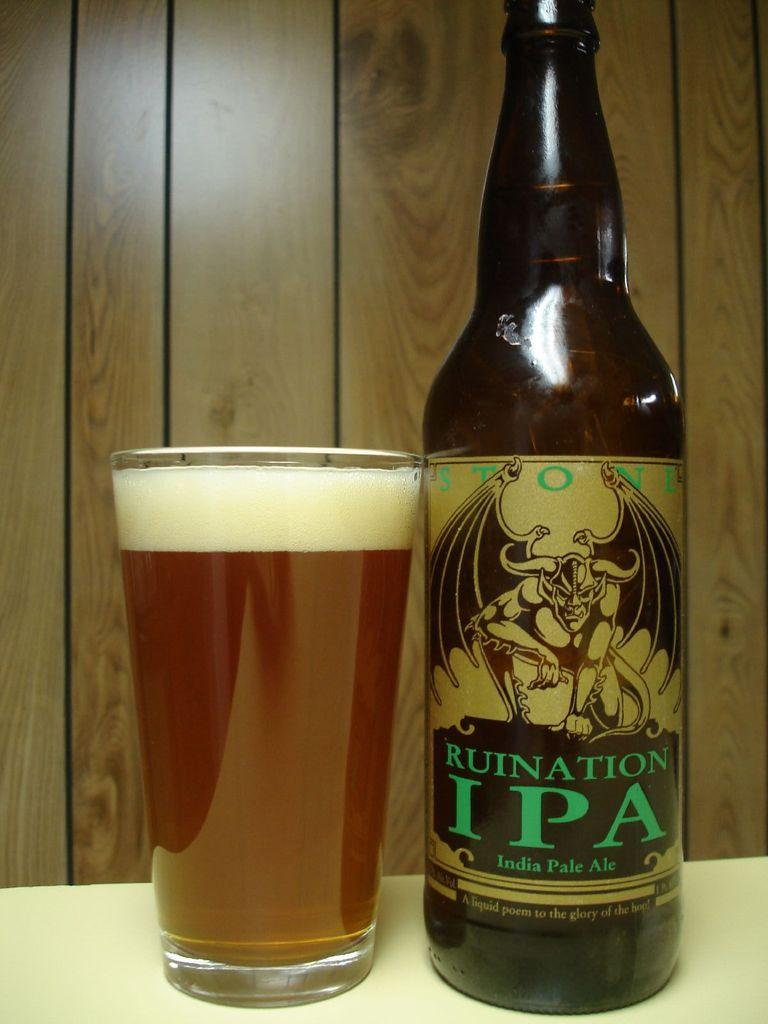What is contained in the glass that is visible in the image? There is a glass with liquid in the image. What other object can be seen on the table in the image? There is a bottle on the table in the image. What type of material is used for the background in the image? The background of the image appears to be a wooden wall. How does the cart interact with the rail in the image? There is no cart or rail present in the image. What is the reason for the stop in the image? There is no stop or indication of a pause in the image. 